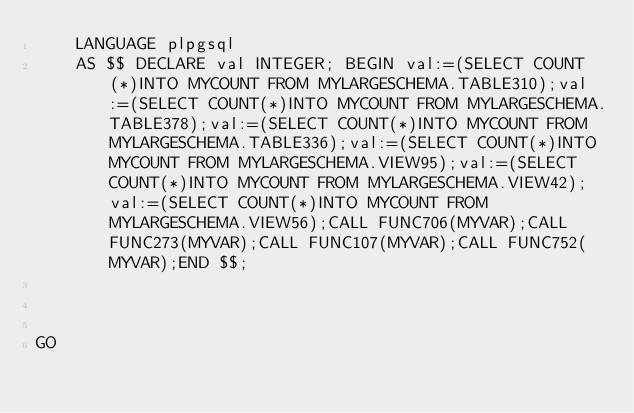<code> <loc_0><loc_0><loc_500><loc_500><_SQL_>    LANGUAGE plpgsql
    AS $$ DECLARE val INTEGER; BEGIN val:=(SELECT COUNT(*)INTO MYCOUNT FROM MYLARGESCHEMA.TABLE310);val:=(SELECT COUNT(*)INTO MYCOUNT FROM MYLARGESCHEMA.TABLE378);val:=(SELECT COUNT(*)INTO MYCOUNT FROM MYLARGESCHEMA.TABLE336);val:=(SELECT COUNT(*)INTO MYCOUNT FROM MYLARGESCHEMA.VIEW95);val:=(SELECT COUNT(*)INTO MYCOUNT FROM MYLARGESCHEMA.VIEW42);val:=(SELECT COUNT(*)INTO MYCOUNT FROM MYLARGESCHEMA.VIEW56);CALL FUNC706(MYVAR);CALL FUNC273(MYVAR);CALL FUNC107(MYVAR);CALL FUNC752(MYVAR);END $$;



GO</code> 